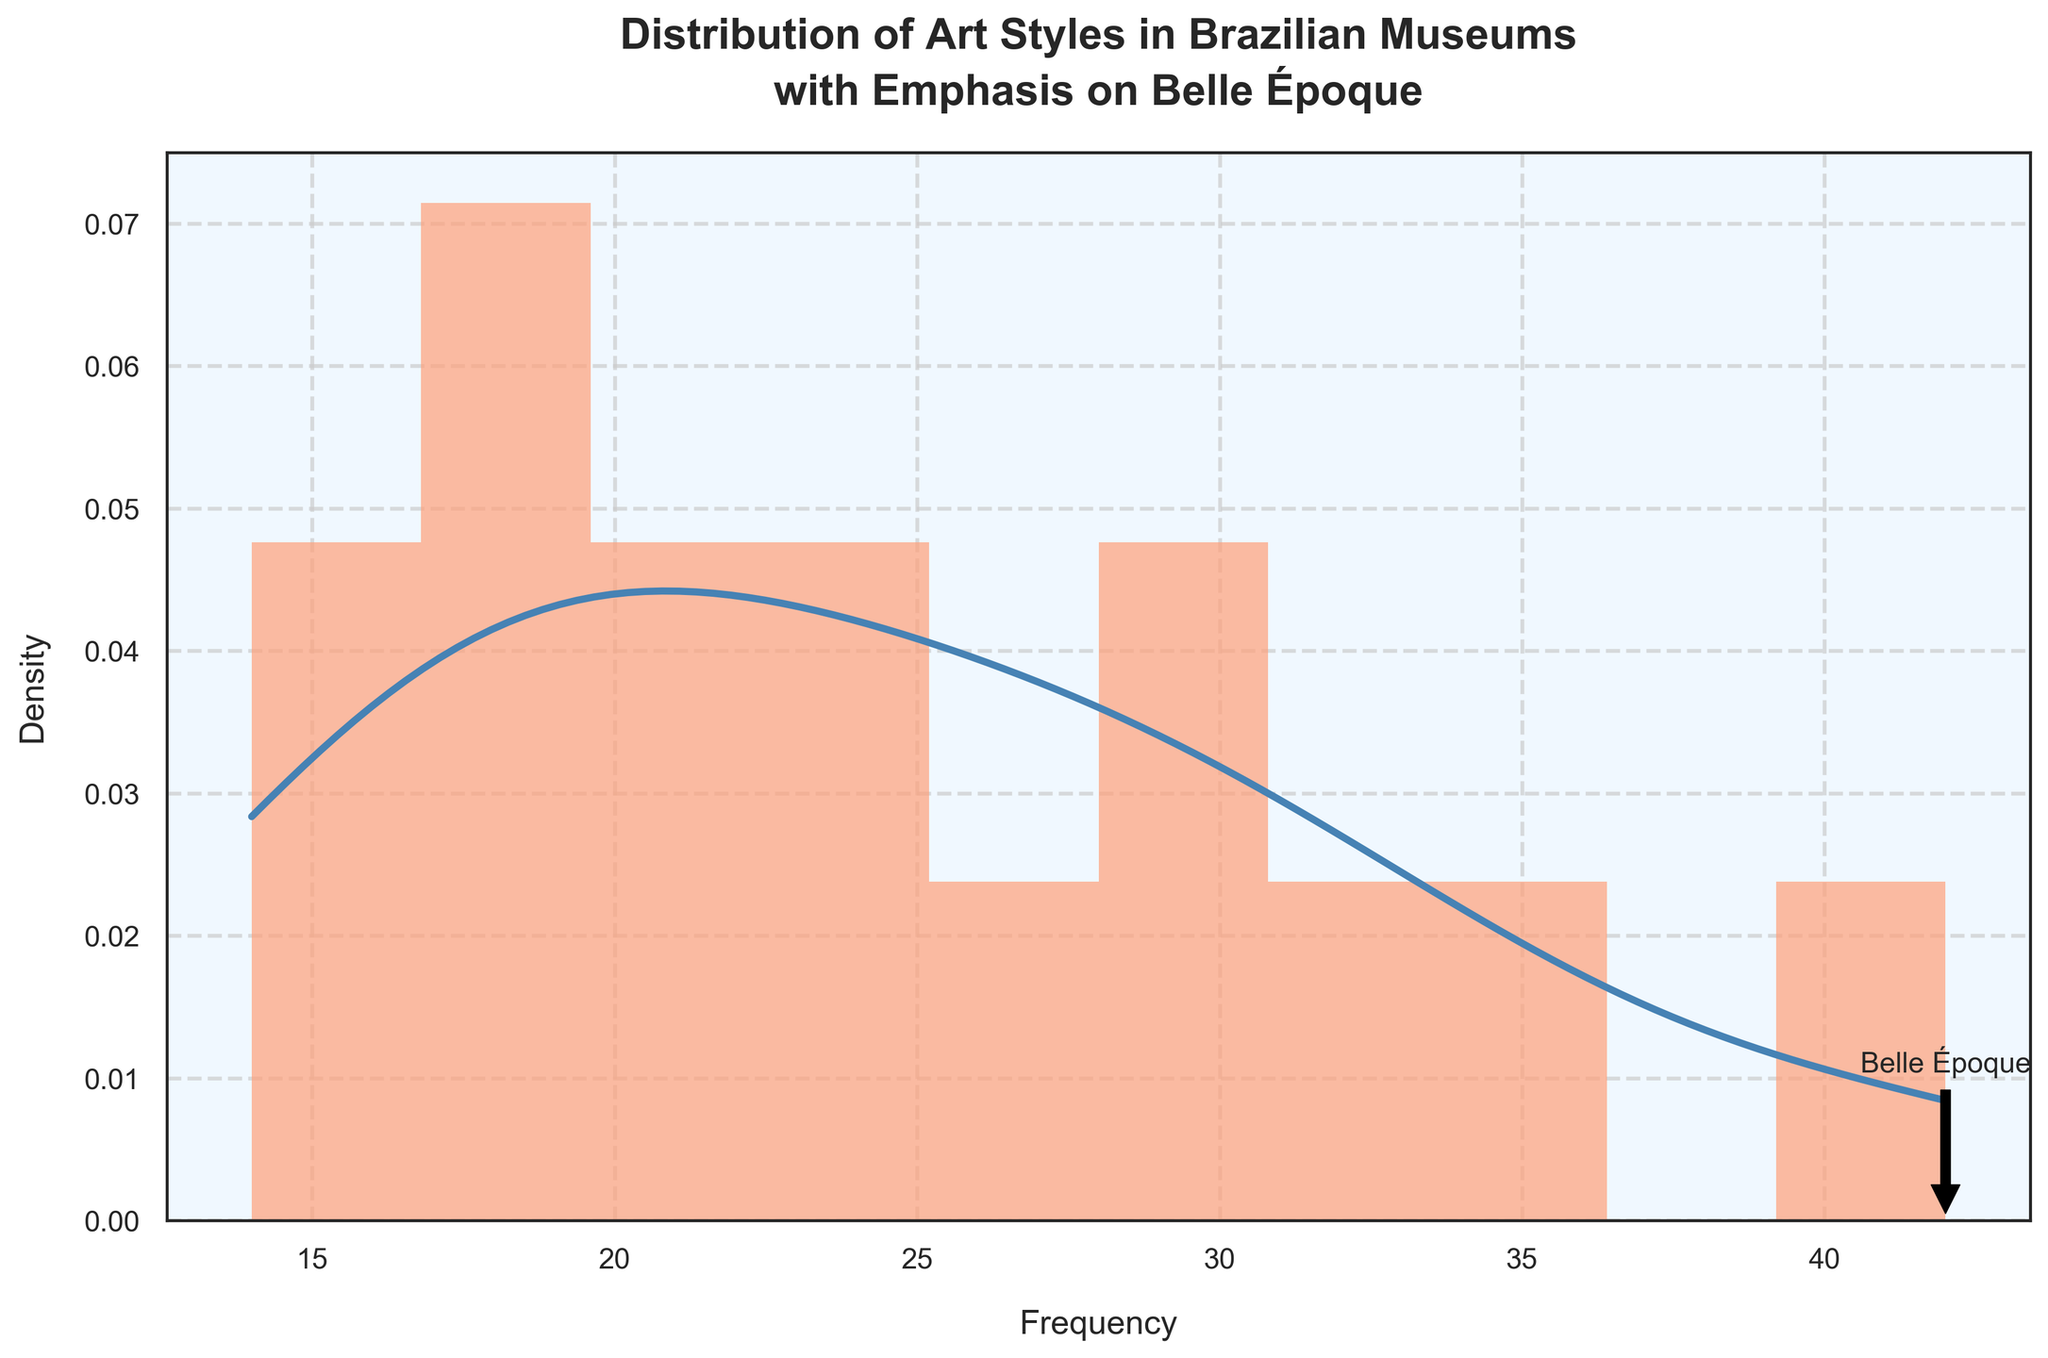what is the highest frequency depicted in the histogram? The histogram visually shows that the highest bar corresponds to the Belle Époque art style, which has a frequency of 42.
Answer: 42 which art style has the highest representation in Brazilian museums? By looking at the histogram, the tallest bar corresponds to the Belle Époque art style. The annotation confirms its frequency as well.
Answer: Belle Époque what is the range of art styles' frequencies? The histogram depicts various art styles with frequencies ranging from the lowest at 14 to the highest at 42.
Answer: 14 to 42 how does the frequency of Impressionism compare to that of Belle Époque? The histogram shows that Impressionism has a bar lower than Belle Époque; specifically, Impressionism has a frequency of 35 while Belle Époque has 42.
Answer: Belle Époque is higher what are the two art styles with the closest frequencies, and what are their values? By comparing the heights of the bars in the histogram, Neoclassicism and Academic Art appear to have very close frequencies of 22 and 23, respectively.
Answer: Neoclassicism (22) and Academic Art (23) which part of the histogram does the KDE curve peak? The KDE curve reaches its highest point near the frequency that aligns with the Belle Époque column, around the frequency of 42.
Answer: Around 42 what is the average frequency of the art styles shown in the histogram? Sum the frequencies (18+22+15+28+35+42+30+25+20+32+17+23+19+27+14) to get 367. There are 15 art styles, so the average frequency is 367 / 15 ≈ 24.47.
Answer: 24.47 what are the five most frequent art styles and their frequencies? Observing the histogram, the five bars with the highest frequencies correspond to Belle Époque (42), Post-Impressionism (32), Art Nouveau (30), Impressionism (35), and Realism (28).
Answer: Belle Époque (42), Post-Impressionism (32), Art Nouveau (30), Impressionism (35), Realism (28) what is the frequency of the least represented art style? The histogram shows the shortest bar corresponds to Orientalism, which has a frequency of 14.
Answer: 14 